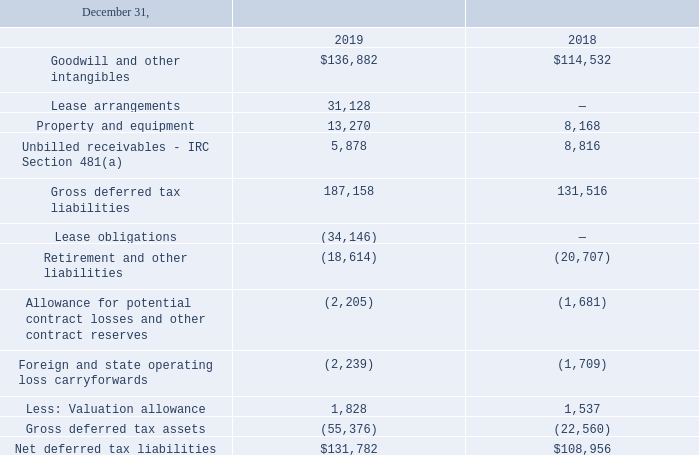Deferred income taxes arise from temporary differences between the tax basis of assets and liabilities and their reported amounts in the financial statements. A summary of the tax effect of the significant components of deferred income taxes is as follows (in thousands):
At December 31, 2019, we had state and foreign net operating losses of approximately $12.2 million and $7.9 million, respectively. The state net operating losses expire beginning 2027 through 2038. We recorded a full valuation allowance against the foreign net operating losses and a partial valuation allowance against the state net operating losses, as we do not believe those losses will be fully utilized in the future.
How do deferred income taxes arise? From temporary differences between the tax basis of assets and liabilities and their reported amounts in the financial statements. How much were the state and foreign net operating losses at December 31, 2019 respectively? $12.2 million, $7.9 million. How much was the net deferred tax liabilities on December 31, 2018?
Answer scale should be: thousand. $108,956. What is the percentage change in net deferred tax liabilities from December 31, 2018, to 2019?
Answer scale should be: percent. ($131,782-$108,956)/$108,956 
Answer: 20.95. What is the ratio of gross deferred tax to net deferred tax liabilities on December 31, 2018? 131,516/108,956 
Answer: 1.21. What is the proportion of the sum of lease arrangements and unbilled receivables over gross deferred tax liabilities on December 31, 2019? (31,128+ 5,878)/187,158 
Answer: 0.2. 